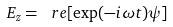<formula> <loc_0><loc_0><loc_500><loc_500>E _ { z } = \ r e [ \exp ( - i \omega t ) \psi ]</formula> 